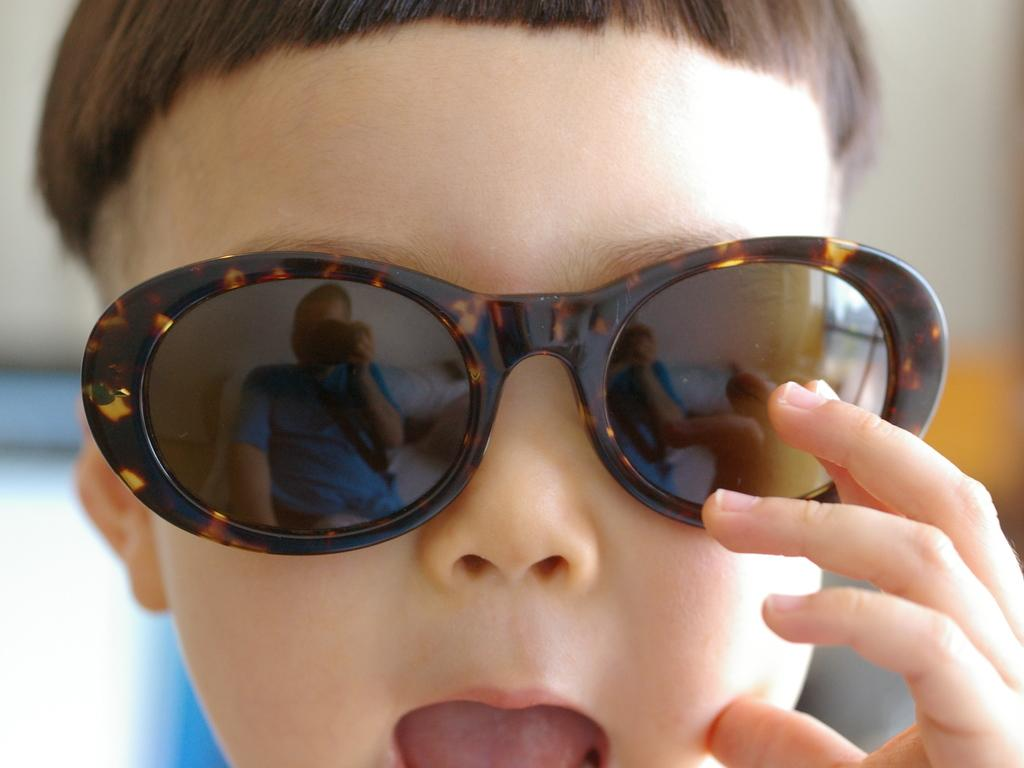What accessory is on the kid's face in the image? There are sunglasses on a kid's face in the image. Can you describe the background of the image? The background of the image is blurred. What type of shame can be seen on the kid's face in the image? There is no shame visible on the kid's face in the image; it only shows the sunglasses. What reason might the kid have for using a fork in the image? There is no fork present in the image, so it is not possible to determine a reason for using one. 